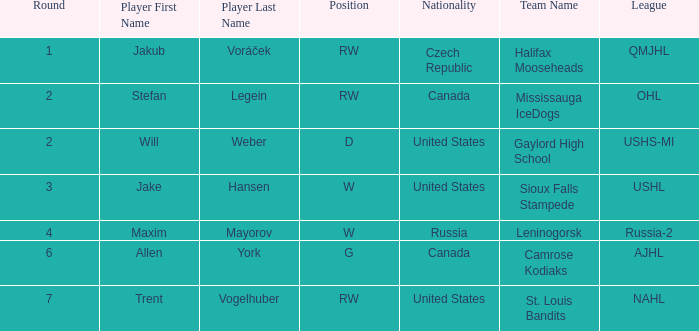What nationality was the round 6 draft pick? Canada. Can you parse all the data within this table? {'header': ['Round', 'Player First Name', 'Player Last Name', 'Position', 'Nationality', 'Team Name', 'League'], 'rows': [['1', 'Jakub', 'Voráček', 'RW', 'Czech Republic', 'Halifax Mooseheads', 'QMJHL'], ['2', 'Stefan', 'Legein', 'RW', 'Canada', 'Mississauga IceDogs', 'OHL'], ['2', 'Will', 'Weber', 'D', 'United States', 'Gaylord High School', 'USHS-MI'], ['3', 'Jake', 'Hansen', 'W', 'United States', 'Sioux Falls Stampede', 'USHL'], ['4', 'Maxim', 'Mayorov', 'W', 'Russia', 'Leninogorsk', 'Russia-2'], ['6', 'Allen', 'York', 'G', 'Canada', 'Camrose Kodiaks', 'AJHL'], ['7', 'Trent', 'Vogelhuber', 'RW', 'United States', 'St. Louis Bandits', 'NAHL']]} 